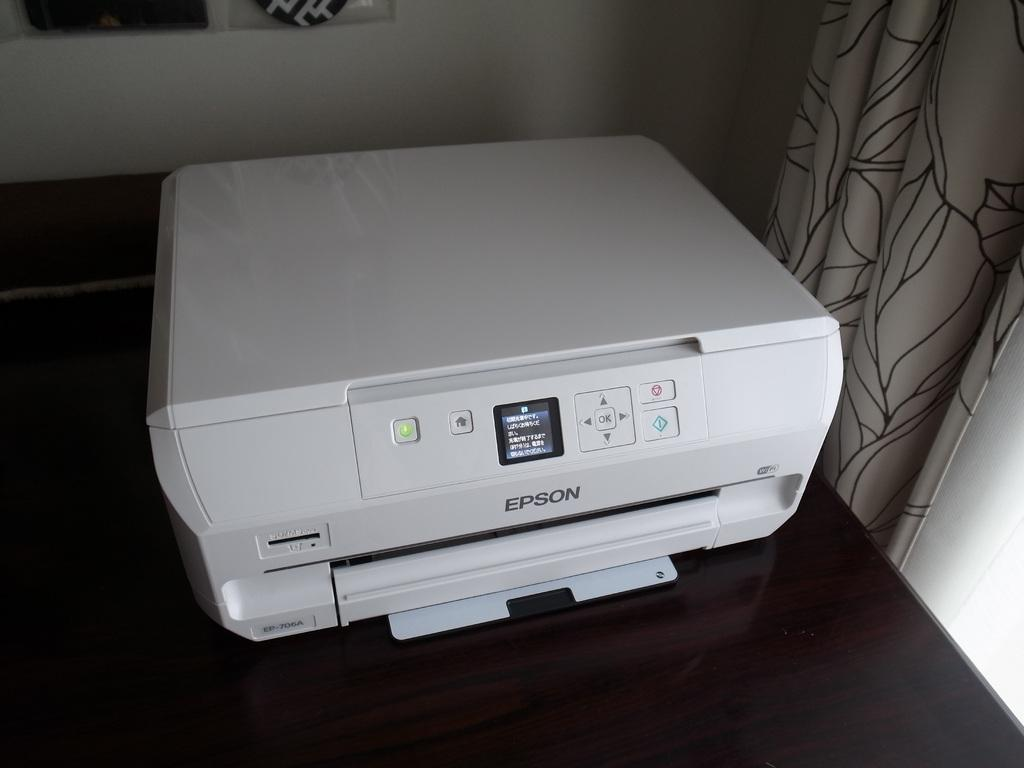What is the main object in the image? There is a printer in the image. Where is the printer located? The printer is on a platform. What can be seen in the background of the image? There is a wall and a curtain in the background of the image. Is there a flame coming from the printer in the image? No, there is no flame present in the image. 